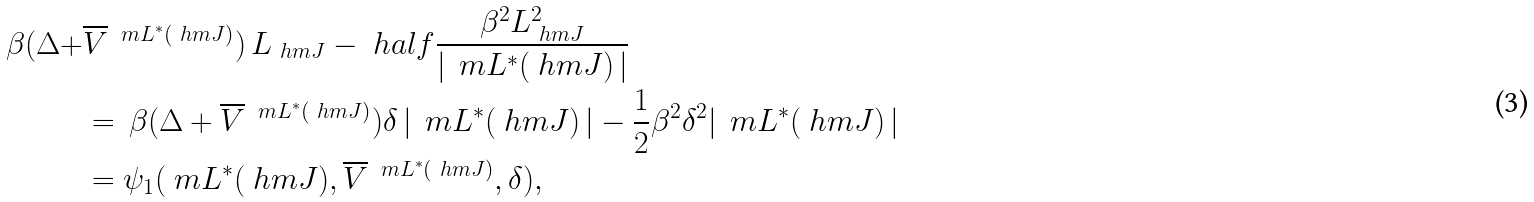Convert formula to latex. <formula><loc_0><loc_0><loc_500><loc_500>\beta ( \Delta + & \overline { V } \, ^ { \ m L ^ { * } ( \ h m J ) } ) \, L _ { \ h m J } - \ h a l f \frac { \beta ^ { 2 } L _ { \ h m J } ^ { 2 } } { | \, \ m L ^ { * } ( \ h m J ) \, | } \, \\ & = \, \beta ( \Delta + \overline { V } \, ^ { \ m L ^ { * } ( \ h m J ) } ) \delta \, | \, \ m L ^ { * } ( \ h m J ) \, | - \frac { 1 } { 2 } \beta ^ { 2 } \delta ^ { 2 } | \, \ m L ^ { * } ( \ h m J ) \, | \\ & = \psi _ { 1 } ( \ m L ^ { * } ( \ h m J ) , \overline { V } \, ^ { \ m L ^ { * } ( \ h m J ) } , \delta ) ,</formula> 